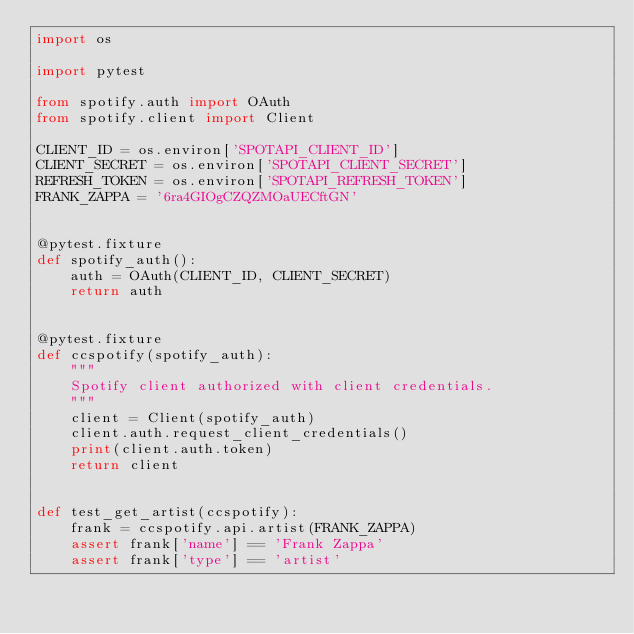<code> <loc_0><loc_0><loc_500><loc_500><_Python_>import os

import pytest

from spotify.auth import OAuth
from spotify.client import Client

CLIENT_ID = os.environ['SPOTAPI_CLIENT_ID']
CLIENT_SECRET = os.environ['SPOTAPI_CLIENT_SECRET']
REFRESH_TOKEN = os.environ['SPOTAPI_REFRESH_TOKEN']
FRANK_ZAPPA = '6ra4GIOgCZQZMOaUECftGN'


@pytest.fixture
def spotify_auth():
    auth = OAuth(CLIENT_ID, CLIENT_SECRET)
    return auth


@pytest.fixture
def ccspotify(spotify_auth):
    """
    Spotify client authorized with client credentials.
    """
    client = Client(spotify_auth)
    client.auth.request_client_credentials()
    print(client.auth.token)
    return client


def test_get_artist(ccspotify):
    frank = ccspotify.api.artist(FRANK_ZAPPA)
    assert frank['name'] == 'Frank Zappa'
    assert frank['type'] == 'artist'
</code> 